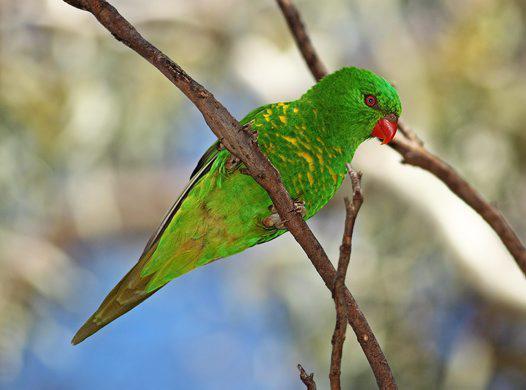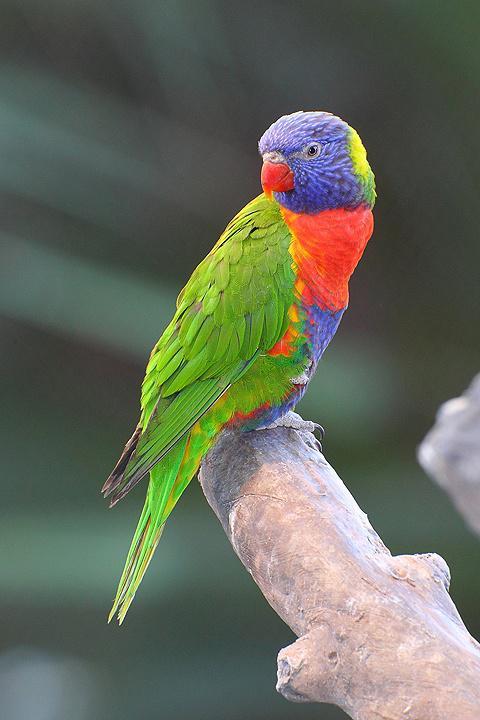The first image is the image on the left, the second image is the image on the right. Considering the images on both sides, is "There is exactly one bird in the iamge on the right" valid? Answer yes or no. Yes. The first image is the image on the left, the second image is the image on the right. For the images displayed, is the sentence "All parrots have green body feathers and red beaks." factually correct? Answer yes or no. No. 